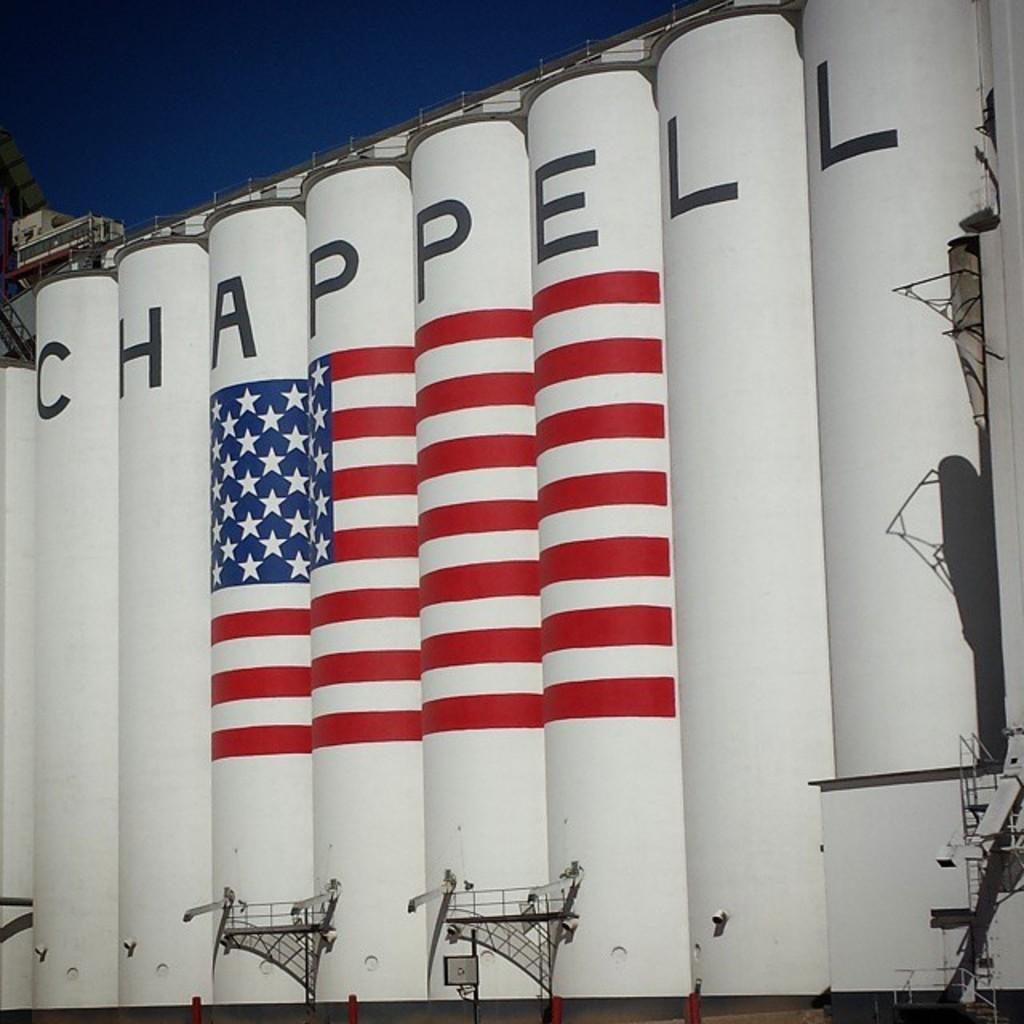What type of location is depicted in the image? There is a shipyard in the image. What can be seen in the sky in the image? The sky is visible at the top of the image. What type of toothbrush is being used to clean the ship in the image? There is no toothbrush present in the image, as it is a shipyard and not a bathroom. 